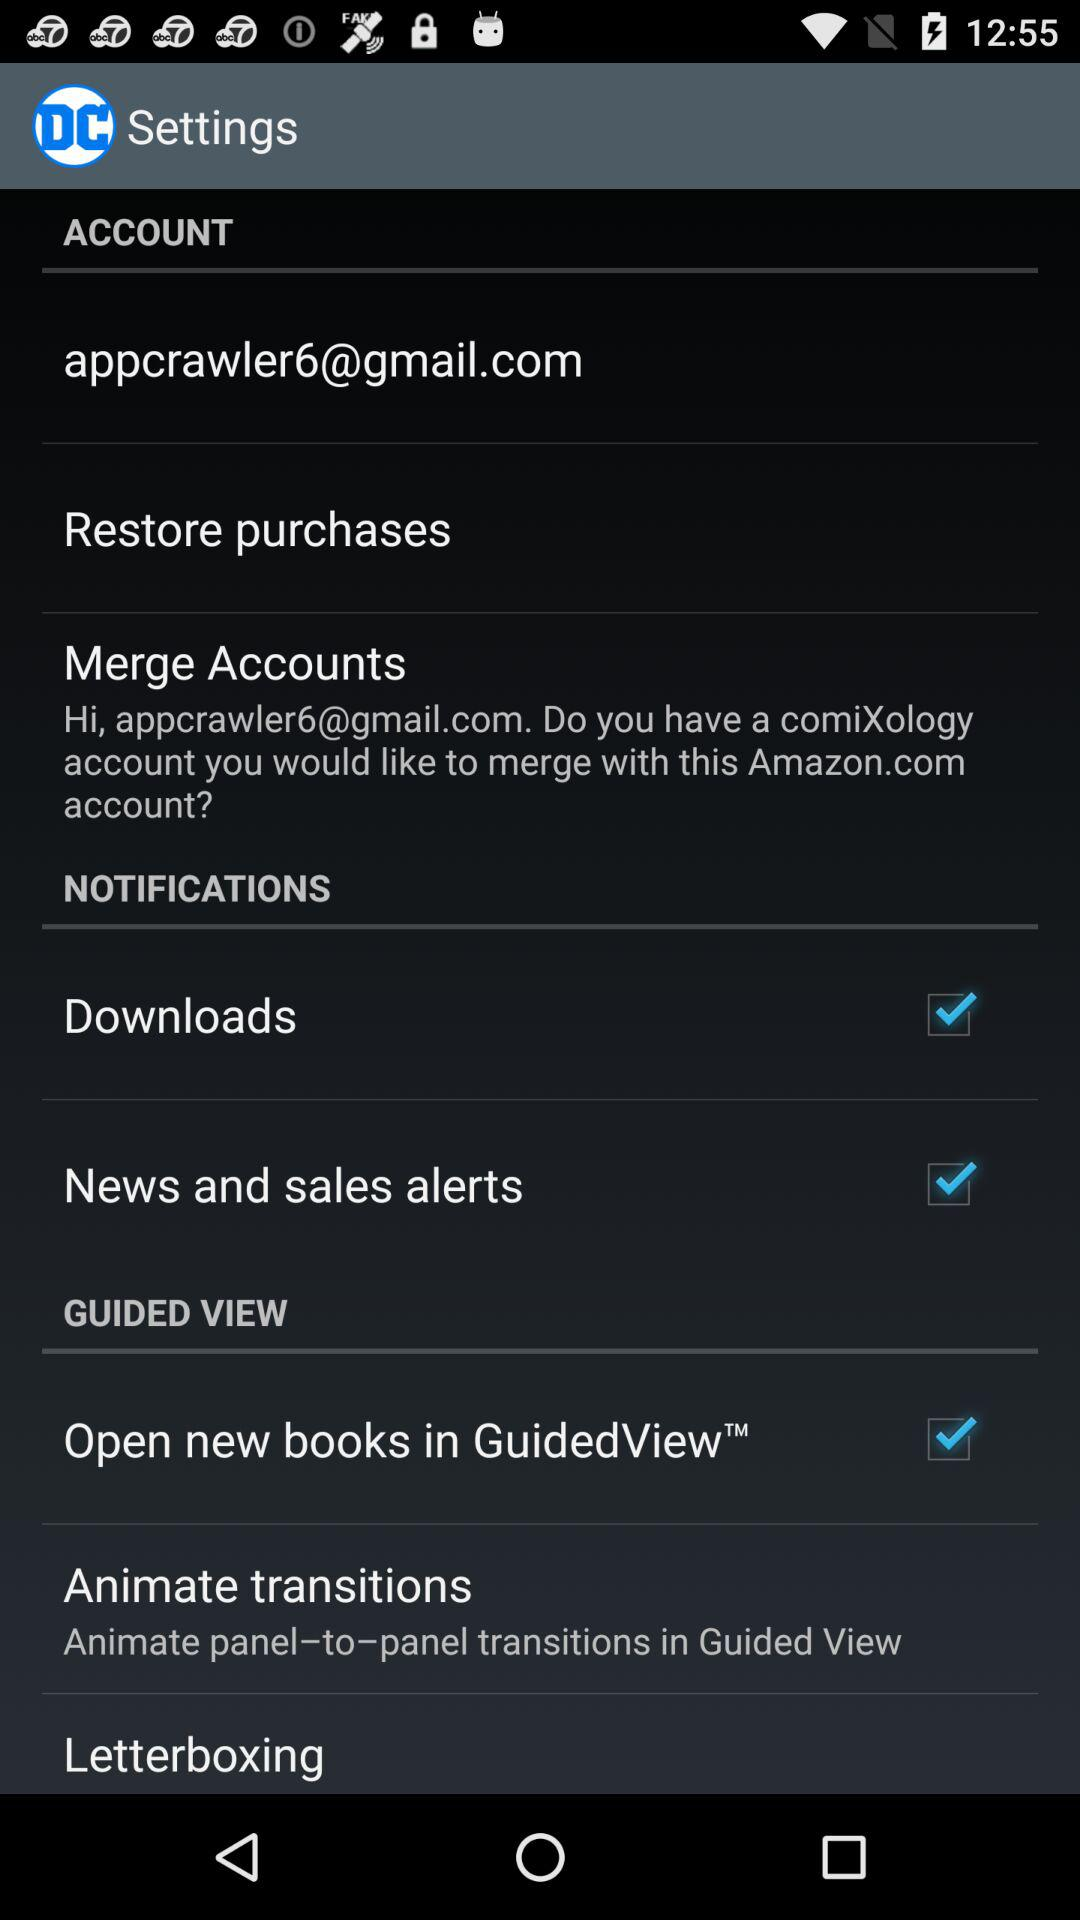What is the status of "Downloads"? The status is "on". 